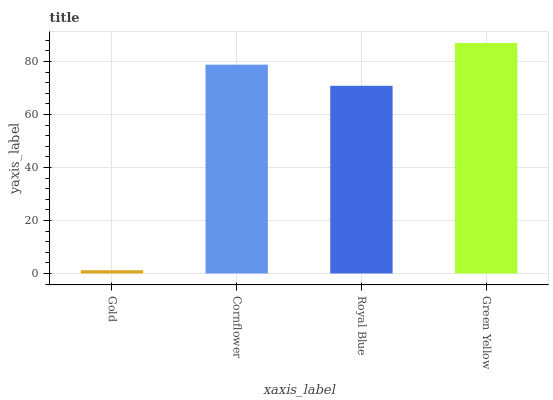Is Gold the minimum?
Answer yes or no. Yes. Is Green Yellow the maximum?
Answer yes or no. Yes. Is Cornflower the minimum?
Answer yes or no. No. Is Cornflower the maximum?
Answer yes or no. No. Is Cornflower greater than Gold?
Answer yes or no. Yes. Is Gold less than Cornflower?
Answer yes or no. Yes. Is Gold greater than Cornflower?
Answer yes or no. No. Is Cornflower less than Gold?
Answer yes or no. No. Is Cornflower the high median?
Answer yes or no. Yes. Is Royal Blue the low median?
Answer yes or no. Yes. Is Royal Blue the high median?
Answer yes or no. No. Is Cornflower the low median?
Answer yes or no. No. 